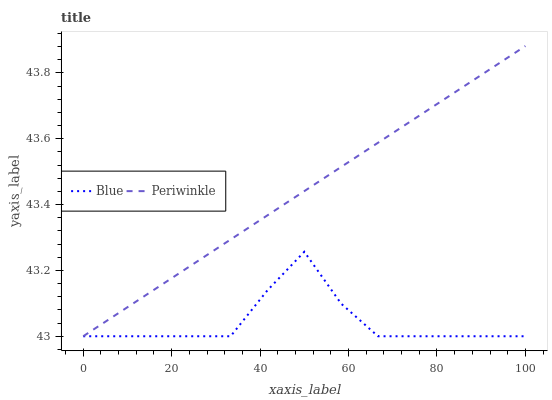Does Blue have the minimum area under the curve?
Answer yes or no. Yes. Does Periwinkle have the maximum area under the curve?
Answer yes or no. Yes. Does Periwinkle have the minimum area under the curve?
Answer yes or no. No. Is Periwinkle the smoothest?
Answer yes or no. Yes. Is Blue the roughest?
Answer yes or no. Yes. Is Periwinkle the roughest?
Answer yes or no. No. Does Periwinkle have the highest value?
Answer yes or no. Yes. Does Periwinkle intersect Blue?
Answer yes or no. Yes. Is Periwinkle less than Blue?
Answer yes or no. No. Is Periwinkle greater than Blue?
Answer yes or no. No. 